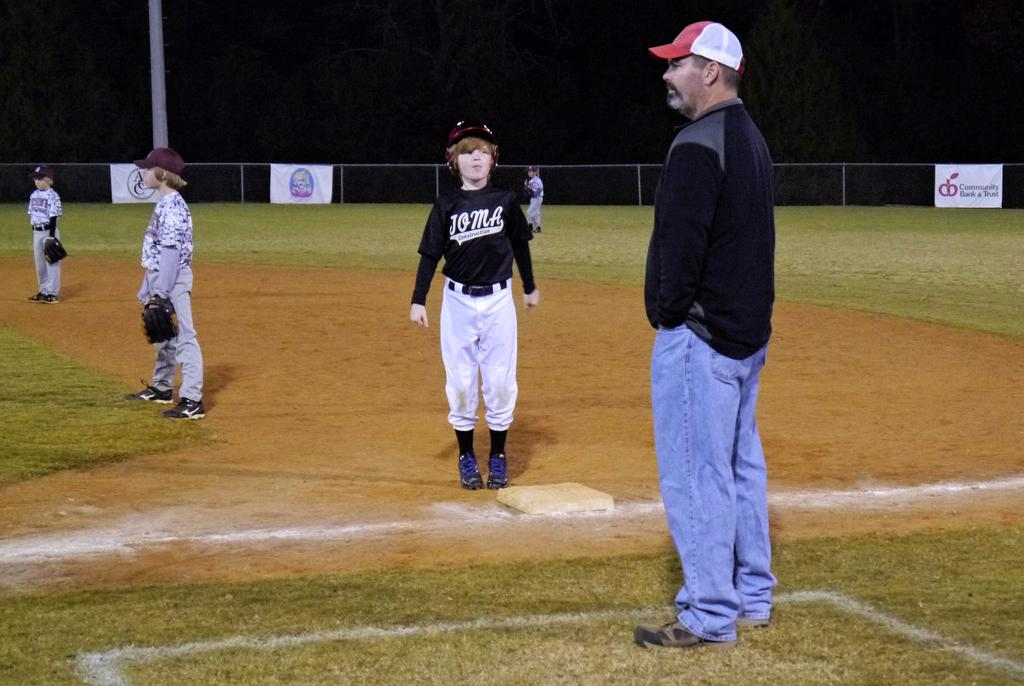<image>
Provide a brief description of the given image. children playing baseball and sign on fence for community bank & trust 